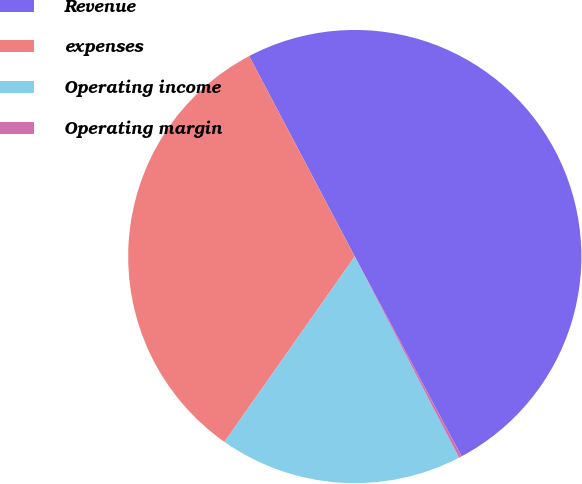Convert chart to OTSL. <chart><loc_0><loc_0><loc_500><loc_500><pie_chart><fcel>Revenue<fcel>expenses<fcel>Operating income<fcel>Operating margin<nl><fcel>49.9%<fcel>32.53%<fcel>17.37%<fcel>0.2%<nl></chart> 